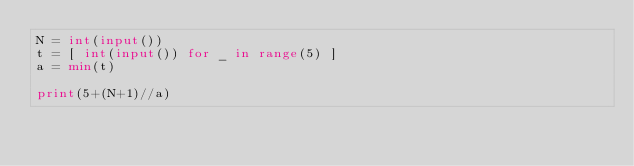Convert code to text. <code><loc_0><loc_0><loc_500><loc_500><_Python_>N = int(input())
t = [ int(input()) for _ in range(5) ]
a = min(t)
 
print(5+(N+1)//a)</code> 